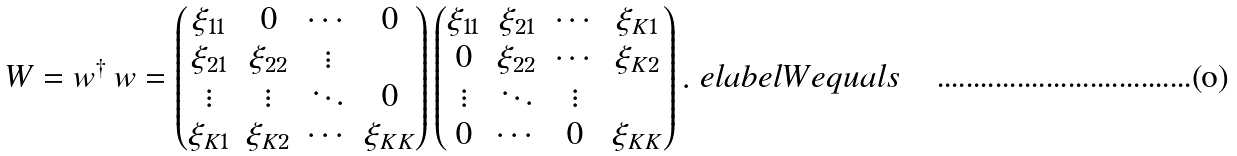Convert formula to latex. <formula><loc_0><loc_0><loc_500><loc_500>W = w ^ { \dagger } \, w = \begin{pmatrix} \xi _ { 1 1 } & 0 & \cdots & 0 \\ \xi _ { 2 1 } & \xi _ { 2 2 } & \vdots \\ \vdots & \vdots & \ddots & 0 \\ \xi _ { K 1 } & \xi _ { K 2 } & \cdots & \xi _ { K K } \end{pmatrix} \begin{pmatrix} \xi _ { 1 1 } & \xi _ { 2 1 } & \cdots & \xi _ { K 1 } \\ 0 & \xi _ { 2 2 } & \cdots & \xi _ { K 2 } \\ \vdots & \ddots & \vdots \\ 0 & \cdots & 0 & \xi _ { K K } \end{pmatrix} . \ e l a b e l { W e q u a l s }</formula> 